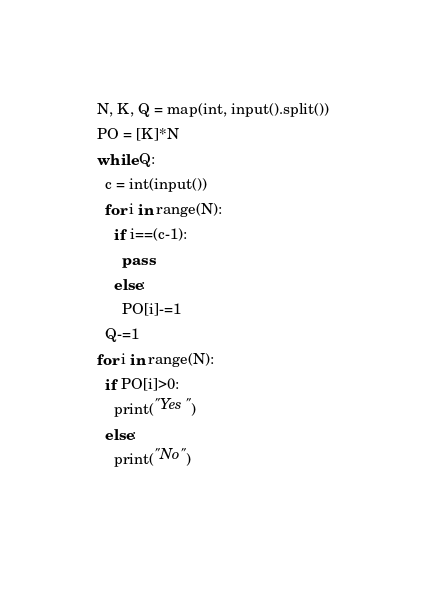<code> <loc_0><loc_0><loc_500><loc_500><_Python_>N, K, Q = map(int, input().split())
PO = [K]*N
while Q:
  c = int(input())
  for i in range(N):
    if i==(c-1):
      pass
    else:
      PO[i]-=1
  Q-=1
for i in range(N):
  if PO[i]>0:
    print("Yes")
  else:
    print("No")
    </code> 